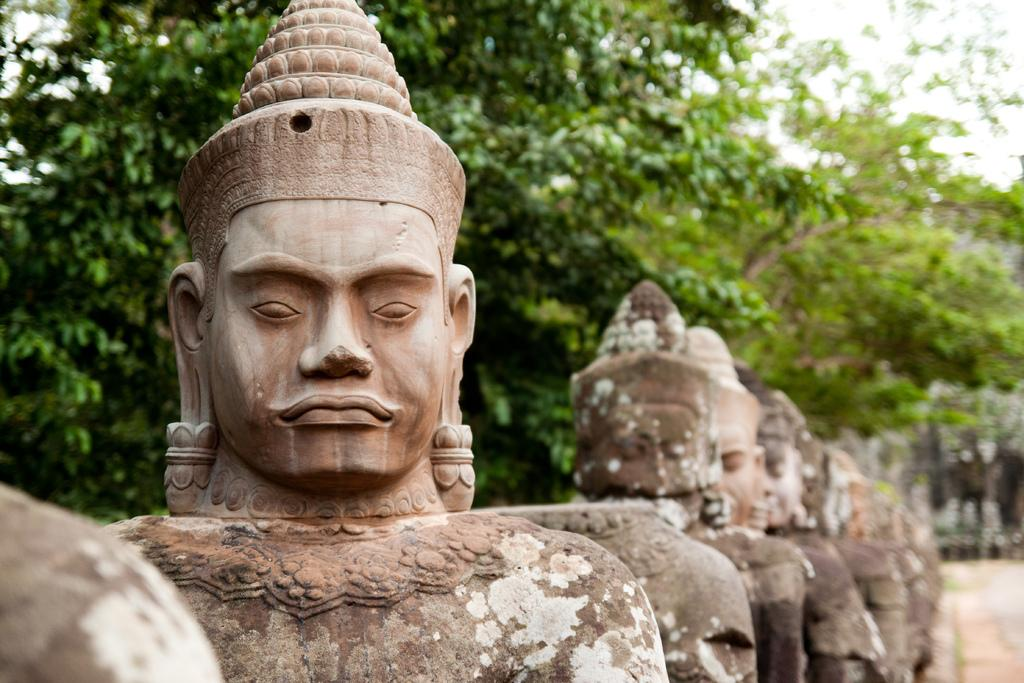What type of art is present in the image? The image contains sculptures. What can be seen in the background of the image? There are trees in the background of the image. What is visible at the top of the image? The sky is visible at the top of the image. What part of the ground is visible in the image? The ground is visible at the bottom right of the image. How many slaves are depicted in the image? There is no depiction of slaves in the image; it contains sculptures and natural elements. 